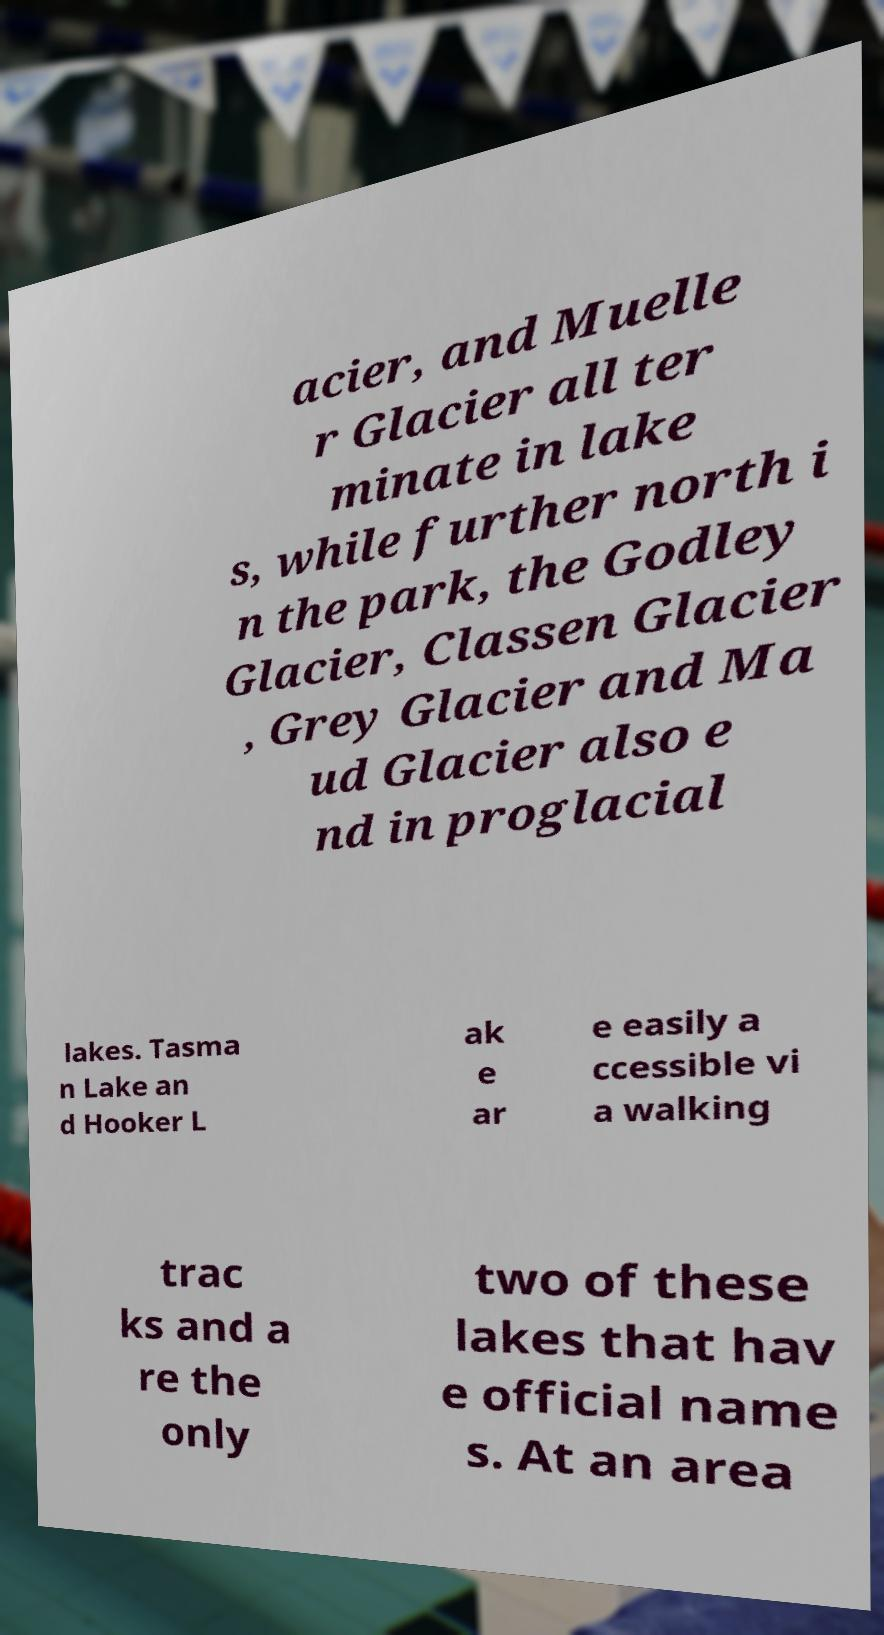For documentation purposes, I need the text within this image transcribed. Could you provide that? acier, and Muelle r Glacier all ter minate in lake s, while further north i n the park, the Godley Glacier, Classen Glacier , Grey Glacier and Ma ud Glacier also e nd in proglacial lakes. Tasma n Lake an d Hooker L ak e ar e easily a ccessible vi a walking trac ks and a re the only two of these lakes that hav e official name s. At an area 